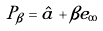Convert formula to latex. <formula><loc_0><loc_0><loc_500><loc_500>P _ { \beta } = \hat { a } + \beta e _ { \infty }</formula> 